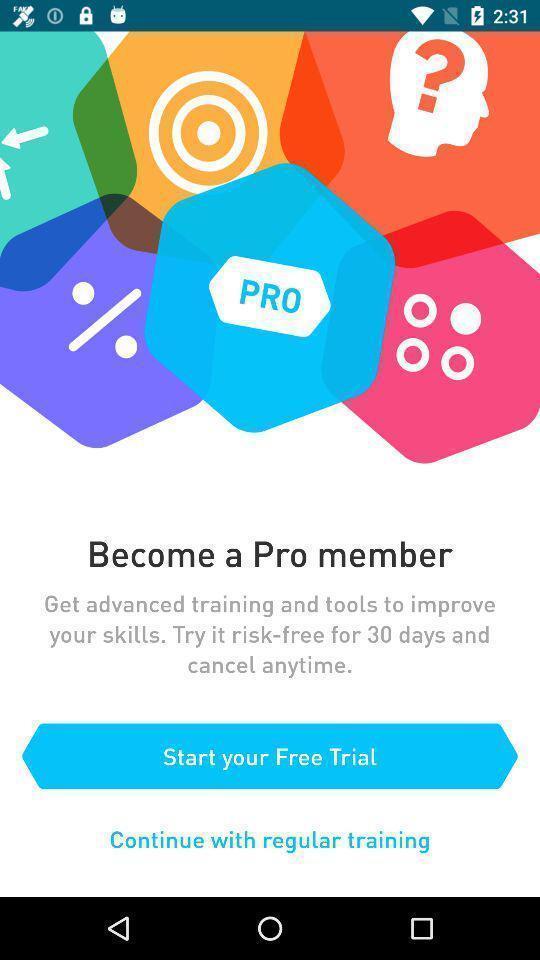Describe the key features of this screenshot. Welcome page of an a applications. 